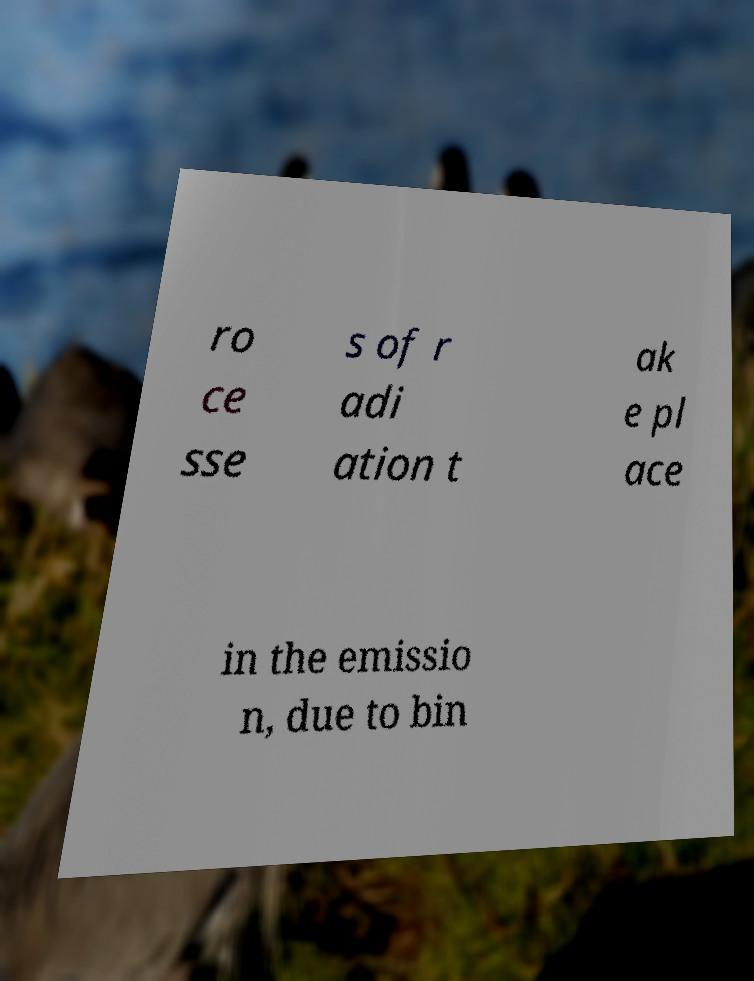Could you assist in decoding the text presented in this image and type it out clearly? ro ce sse s of r adi ation t ak e pl ace in the emissio n, due to bin 